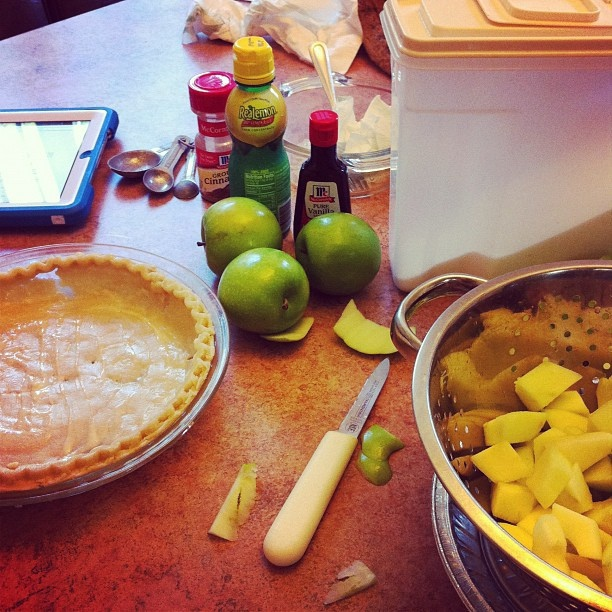Describe the objects in this image and their specific colors. I can see dining table in brown, darkgray, maroon, and lightgray tones, bowl in black, orange, brown, maroon, and gold tones, apple in black, orange, red, and gold tones, apple in black and olive tones, and bowl in black, tan, darkgray, and brown tones in this image. 